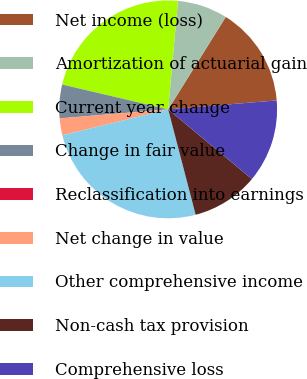Convert chart. <chart><loc_0><loc_0><loc_500><loc_500><pie_chart><fcel>Net income (loss)<fcel>Amortization of actuarial gain<fcel>Current year change<fcel>Change in fair value<fcel>Reclassification into earnings<fcel>Net change in value<fcel>Other comprehensive income<fcel>Non-cash tax provision<fcel>Comprehensive loss<nl><fcel>14.82%<fcel>7.43%<fcel>22.77%<fcel>4.96%<fcel>0.03%<fcel>2.5%<fcel>25.23%<fcel>9.89%<fcel>12.36%<nl></chart> 